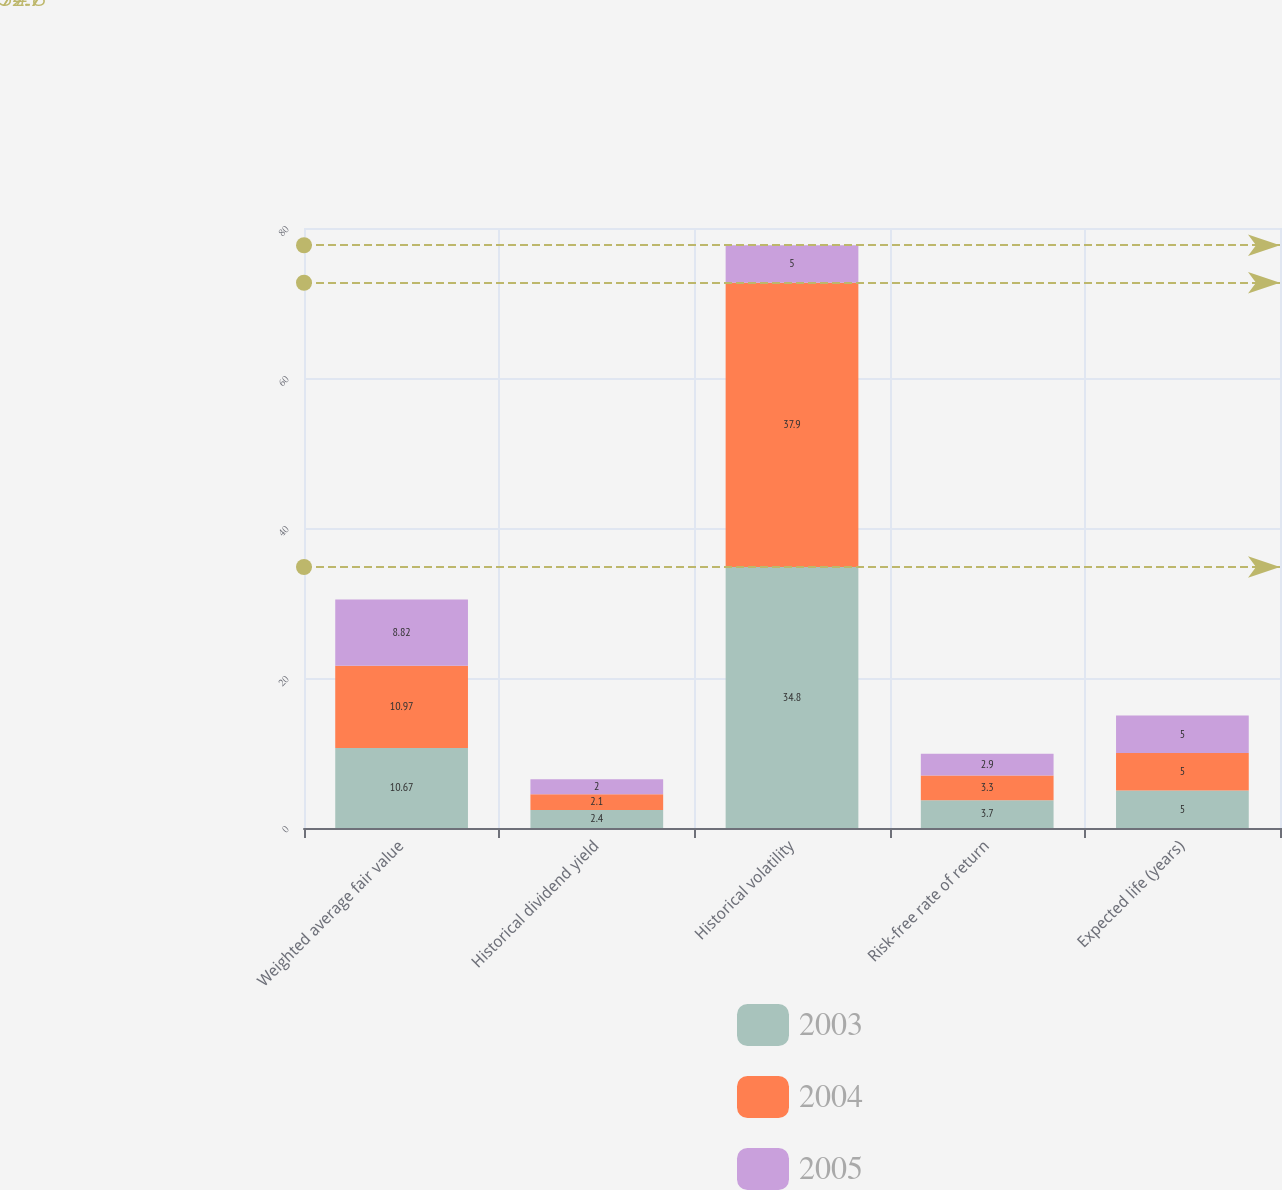Convert chart to OTSL. <chart><loc_0><loc_0><loc_500><loc_500><stacked_bar_chart><ecel><fcel>Weighted average fair value<fcel>Historical dividend yield<fcel>Historical volatility<fcel>Risk-free rate of return<fcel>Expected life (years)<nl><fcel>2003<fcel>10.67<fcel>2.4<fcel>34.8<fcel>3.7<fcel>5<nl><fcel>2004<fcel>10.97<fcel>2.1<fcel>37.9<fcel>3.3<fcel>5<nl><fcel>2005<fcel>8.82<fcel>2<fcel>5<fcel>2.9<fcel>5<nl></chart> 